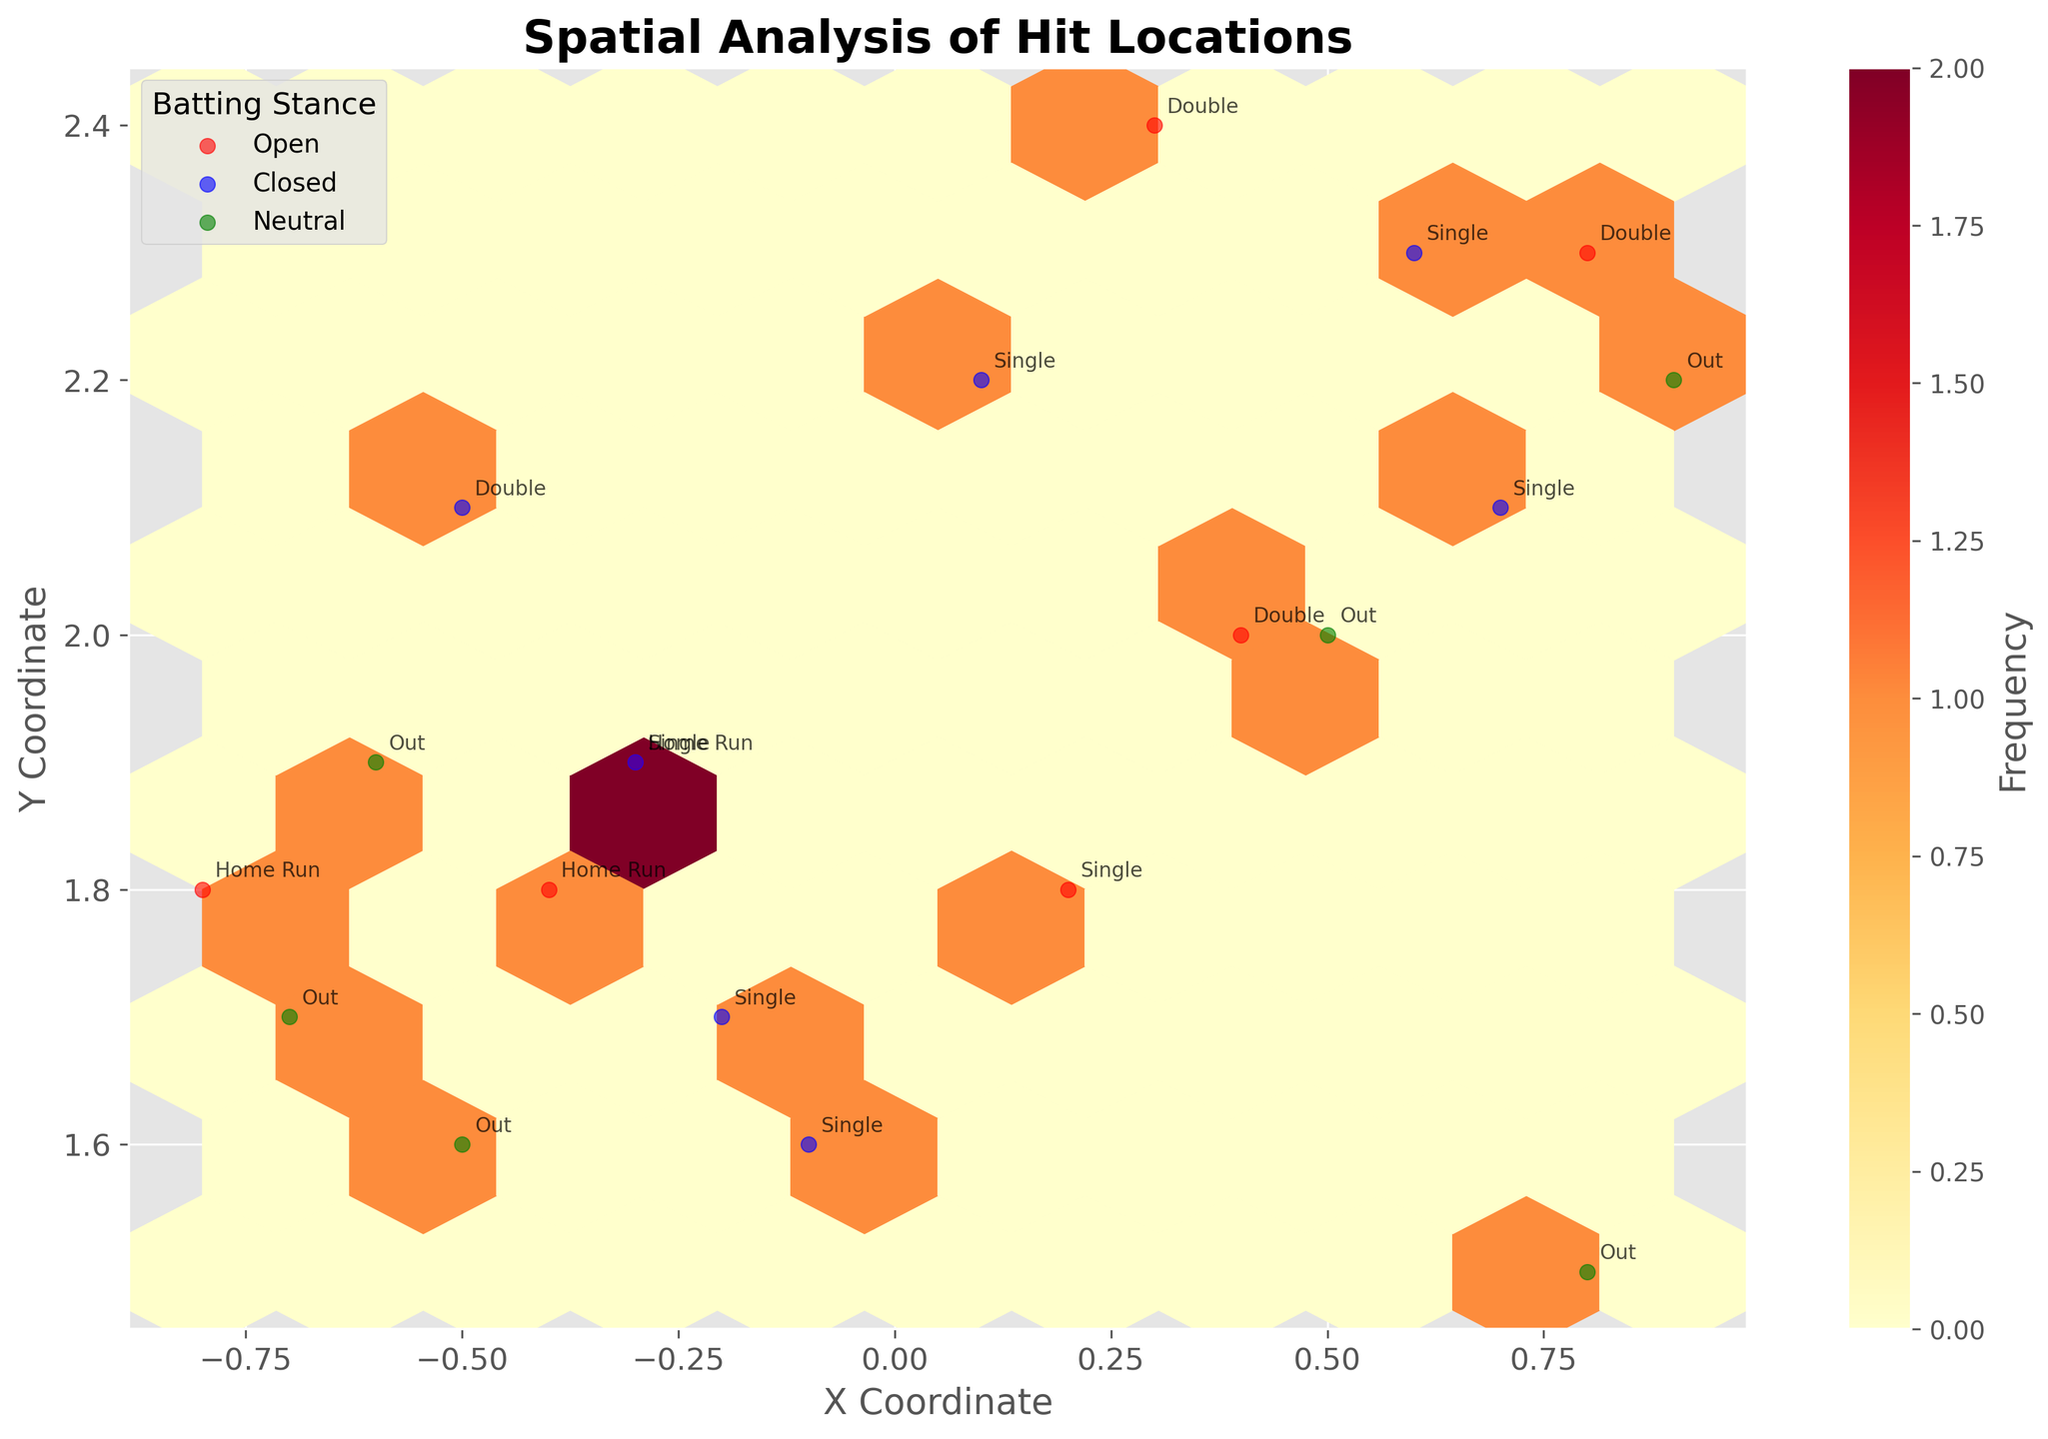What is the title of the plot? The title of the plot can usually be found at the top of the figure. The title in this case is "Spatial Analysis of Hit Locations."
Answer: Spatial Analysis of Hit Locations How many different batting stances are represented in the plot? To determine the number of batting stances, look at the legend located somewhere in the plot area. Each different color in the scatter plot represents a unique batting stance. In the provided data and the plot, they are 'Open', 'Closed', and 'Neutral'.
Answer: 3 Which stance results in the highest frequency of data points? The hexbin plot uses color intensity to indicate frequency. By comparing the different areas where each stance is represented, you can determine which stance accumulates the highest number of data points. Based on the created plot and figure, 'Open' has the highest frequency.
Answer: Open What is the most common outcome for hits located at (0.5, 2.0) and (-0.4, 1.8)? You need to refer to the annotations in the plot which are added to specific data points to indicate outcomes. For these particular coordinates, the annotations indicate 'Out' for (0.5, 2.0) and 'Home Run' for (-0.4, 1.8).
Answer: Out, Home Run Which batting stance has the most diverse spread of hit locations? By evaluating the different colored scatter points and their spread, you can gauge which stance has the widest range of locations. Considering the plot, 'Open' stance shows a more diverse spread compared to the 'Closed' and 'Neutral' stances.
Answer: Open How many home runs were hit by players with an open stance? By looking at the annotations in the plot and focusing only on the points where the 'Open' stance color is used, count the number of 'Home Run' labels. There are specifically 3: by Aaron Judge, Bryce Harper, and Vladimir Guerrero Jr.
Answer: 3 Which batting stance has the highest concentration of hits in the lower left hexagonal bins (closer to the origin)? Look at the hexbin plot and determine which color, representing a batting stance, appears most frequently in the lower bins near the origin. Given the plot, 'Neutral' stance points tend to cluster more around the lower left area.
Answer: Neutral Who hit a double with a closed stance and at which coordinates? Look at the plot and check the 'Closed' stance points and find the one with the outcome labelled 'Double'. By the data and annotations, this was done by José Altuve at coordinates (0.6, 2.3).
Answer: José Altuve, (0.6, 2.3) What is the range of the x coordinates for hits resulting in singles? To find this, look at the annotations for 'Single' outcomes and examine their x coordinates. From the data, the range is determined by the minimum and maximum x values, which are -0.3 and 0.9 respectively.
Answer: -0.3 to 0.9 Which players contributed to the hits located at (0.4, 2.0) and (-0.3, 1.9)? Consult the figure annotations along with the data points listed in the questions. For coordinates (0.4, 2.0) and (-0.3, 1.9), the contributing players are Fernando Tatis Jr. and Carlos Correa respectively.
Answer: Fernando Tatis Jr., Carlos Correa 